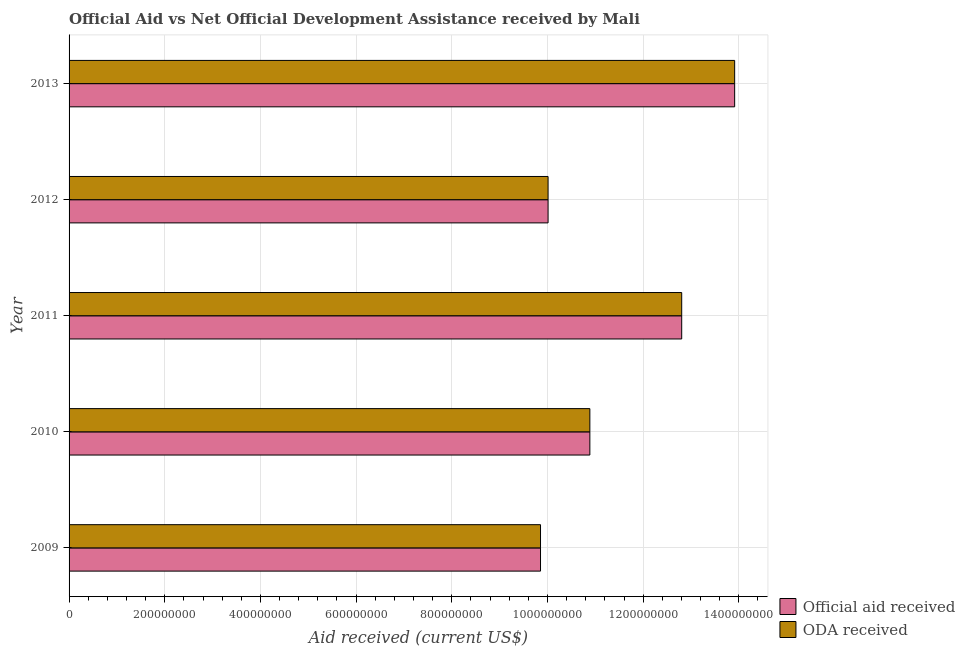Are the number of bars per tick equal to the number of legend labels?
Your answer should be compact. Yes. How many bars are there on the 1st tick from the top?
Provide a short and direct response. 2. In how many cases, is the number of bars for a given year not equal to the number of legend labels?
Offer a terse response. 0. What is the oda received in 2011?
Ensure brevity in your answer.  1.28e+09. Across all years, what is the maximum official aid received?
Provide a short and direct response. 1.39e+09. Across all years, what is the minimum oda received?
Provide a succinct answer. 9.85e+08. In which year was the oda received maximum?
Give a very brief answer. 2013. What is the total oda received in the graph?
Provide a short and direct response. 5.75e+09. What is the difference between the official aid received in 2011 and that in 2013?
Offer a terse response. -1.11e+08. What is the difference between the oda received in 2009 and the official aid received in 2013?
Provide a succinct answer. -4.06e+08. What is the average oda received per year?
Give a very brief answer. 1.15e+09. In the year 2009, what is the difference between the oda received and official aid received?
Keep it short and to the point. 0. In how many years, is the official aid received greater than 80000000 US$?
Give a very brief answer. 5. What is the ratio of the official aid received in 2009 to that in 2013?
Make the answer very short. 0.71. Is the oda received in 2010 less than that in 2013?
Give a very brief answer. Yes. What is the difference between the highest and the second highest oda received?
Provide a succinct answer. 1.11e+08. What is the difference between the highest and the lowest oda received?
Offer a terse response. 4.06e+08. In how many years, is the oda received greater than the average oda received taken over all years?
Give a very brief answer. 2. What does the 2nd bar from the top in 2009 represents?
Give a very brief answer. Official aid received. What does the 1st bar from the bottom in 2013 represents?
Your answer should be compact. Official aid received. What is the difference between two consecutive major ticks on the X-axis?
Provide a succinct answer. 2.00e+08. Where does the legend appear in the graph?
Offer a terse response. Bottom right. How many legend labels are there?
Ensure brevity in your answer.  2. What is the title of the graph?
Give a very brief answer. Official Aid vs Net Official Development Assistance received by Mali . Does "Depositors" appear as one of the legend labels in the graph?
Provide a succinct answer. No. What is the label or title of the X-axis?
Provide a succinct answer. Aid received (current US$). What is the label or title of the Y-axis?
Your response must be concise. Year. What is the Aid received (current US$) in Official aid received in 2009?
Make the answer very short. 9.85e+08. What is the Aid received (current US$) in ODA received in 2009?
Your answer should be compact. 9.85e+08. What is the Aid received (current US$) of Official aid received in 2010?
Offer a terse response. 1.09e+09. What is the Aid received (current US$) of ODA received in 2010?
Ensure brevity in your answer.  1.09e+09. What is the Aid received (current US$) of Official aid received in 2011?
Provide a short and direct response. 1.28e+09. What is the Aid received (current US$) in ODA received in 2011?
Your answer should be compact. 1.28e+09. What is the Aid received (current US$) of Official aid received in 2012?
Your answer should be compact. 1.00e+09. What is the Aid received (current US$) of ODA received in 2012?
Provide a short and direct response. 1.00e+09. What is the Aid received (current US$) of Official aid received in 2013?
Your answer should be compact. 1.39e+09. What is the Aid received (current US$) of ODA received in 2013?
Make the answer very short. 1.39e+09. Across all years, what is the maximum Aid received (current US$) in Official aid received?
Ensure brevity in your answer.  1.39e+09. Across all years, what is the maximum Aid received (current US$) in ODA received?
Your answer should be compact. 1.39e+09. Across all years, what is the minimum Aid received (current US$) in Official aid received?
Your answer should be very brief. 9.85e+08. Across all years, what is the minimum Aid received (current US$) in ODA received?
Give a very brief answer. 9.85e+08. What is the total Aid received (current US$) of Official aid received in the graph?
Offer a very short reply. 5.75e+09. What is the total Aid received (current US$) in ODA received in the graph?
Offer a very short reply. 5.75e+09. What is the difference between the Aid received (current US$) in Official aid received in 2009 and that in 2010?
Provide a succinct answer. -1.03e+08. What is the difference between the Aid received (current US$) in ODA received in 2009 and that in 2010?
Keep it short and to the point. -1.03e+08. What is the difference between the Aid received (current US$) of Official aid received in 2009 and that in 2011?
Offer a very short reply. -2.95e+08. What is the difference between the Aid received (current US$) of ODA received in 2009 and that in 2011?
Provide a short and direct response. -2.95e+08. What is the difference between the Aid received (current US$) in Official aid received in 2009 and that in 2012?
Your answer should be compact. -1.58e+07. What is the difference between the Aid received (current US$) in ODA received in 2009 and that in 2012?
Provide a short and direct response. -1.58e+07. What is the difference between the Aid received (current US$) of Official aid received in 2009 and that in 2013?
Offer a very short reply. -4.06e+08. What is the difference between the Aid received (current US$) in ODA received in 2009 and that in 2013?
Make the answer very short. -4.06e+08. What is the difference between the Aid received (current US$) in Official aid received in 2010 and that in 2011?
Your response must be concise. -1.92e+08. What is the difference between the Aid received (current US$) of ODA received in 2010 and that in 2011?
Your response must be concise. -1.92e+08. What is the difference between the Aid received (current US$) of Official aid received in 2010 and that in 2012?
Ensure brevity in your answer.  8.73e+07. What is the difference between the Aid received (current US$) of ODA received in 2010 and that in 2012?
Your answer should be very brief. 8.73e+07. What is the difference between the Aid received (current US$) of Official aid received in 2010 and that in 2013?
Your answer should be compact. -3.03e+08. What is the difference between the Aid received (current US$) of ODA received in 2010 and that in 2013?
Your answer should be very brief. -3.03e+08. What is the difference between the Aid received (current US$) in Official aid received in 2011 and that in 2012?
Offer a terse response. 2.79e+08. What is the difference between the Aid received (current US$) of ODA received in 2011 and that in 2012?
Give a very brief answer. 2.79e+08. What is the difference between the Aid received (current US$) in Official aid received in 2011 and that in 2013?
Offer a very short reply. -1.11e+08. What is the difference between the Aid received (current US$) of ODA received in 2011 and that in 2013?
Keep it short and to the point. -1.11e+08. What is the difference between the Aid received (current US$) of Official aid received in 2012 and that in 2013?
Your answer should be very brief. -3.90e+08. What is the difference between the Aid received (current US$) in ODA received in 2012 and that in 2013?
Offer a very short reply. -3.90e+08. What is the difference between the Aid received (current US$) in Official aid received in 2009 and the Aid received (current US$) in ODA received in 2010?
Keep it short and to the point. -1.03e+08. What is the difference between the Aid received (current US$) in Official aid received in 2009 and the Aid received (current US$) in ODA received in 2011?
Make the answer very short. -2.95e+08. What is the difference between the Aid received (current US$) in Official aid received in 2009 and the Aid received (current US$) in ODA received in 2012?
Your response must be concise. -1.58e+07. What is the difference between the Aid received (current US$) of Official aid received in 2009 and the Aid received (current US$) of ODA received in 2013?
Your answer should be compact. -4.06e+08. What is the difference between the Aid received (current US$) of Official aid received in 2010 and the Aid received (current US$) of ODA received in 2011?
Ensure brevity in your answer.  -1.92e+08. What is the difference between the Aid received (current US$) in Official aid received in 2010 and the Aid received (current US$) in ODA received in 2012?
Offer a very short reply. 8.73e+07. What is the difference between the Aid received (current US$) of Official aid received in 2010 and the Aid received (current US$) of ODA received in 2013?
Keep it short and to the point. -3.03e+08. What is the difference between the Aid received (current US$) in Official aid received in 2011 and the Aid received (current US$) in ODA received in 2012?
Give a very brief answer. 2.79e+08. What is the difference between the Aid received (current US$) in Official aid received in 2011 and the Aid received (current US$) in ODA received in 2013?
Provide a short and direct response. -1.11e+08. What is the difference between the Aid received (current US$) in Official aid received in 2012 and the Aid received (current US$) in ODA received in 2013?
Offer a very short reply. -3.90e+08. What is the average Aid received (current US$) of Official aid received per year?
Your answer should be compact. 1.15e+09. What is the average Aid received (current US$) of ODA received per year?
Provide a short and direct response. 1.15e+09. In the year 2009, what is the difference between the Aid received (current US$) in Official aid received and Aid received (current US$) in ODA received?
Make the answer very short. 0. In the year 2010, what is the difference between the Aid received (current US$) of Official aid received and Aid received (current US$) of ODA received?
Your answer should be very brief. 0. In the year 2011, what is the difference between the Aid received (current US$) in Official aid received and Aid received (current US$) in ODA received?
Your answer should be very brief. 0. In the year 2013, what is the difference between the Aid received (current US$) of Official aid received and Aid received (current US$) of ODA received?
Make the answer very short. 0. What is the ratio of the Aid received (current US$) of Official aid received in 2009 to that in 2010?
Provide a succinct answer. 0.91. What is the ratio of the Aid received (current US$) of ODA received in 2009 to that in 2010?
Your answer should be compact. 0.91. What is the ratio of the Aid received (current US$) in Official aid received in 2009 to that in 2011?
Make the answer very short. 0.77. What is the ratio of the Aid received (current US$) in ODA received in 2009 to that in 2011?
Keep it short and to the point. 0.77. What is the ratio of the Aid received (current US$) in Official aid received in 2009 to that in 2012?
Your answer should be very brief. 0.98. What is the ratio of the Aid received (current US$) of ODA received in 2009 to that in 2012?
Ensure brevity in your answer.  0.98. What is the ratio of the Aid received (current US$) in Official aid received in 2009 to that in 2013?
Make the answer very short. 0.71. What is the ratio of the Aid received (current US$) of ODA received in 2009 to that in 2013?
Give a very brief answer. 0.71. What is the ratio of the Aid received (current US$) of Official aid received in 2010 to that in 2011?
Offer a very short reply. 0.85. What is the ratio of the Aid received (current US$) of ODA received in 2010 to that in 2011?
Provide a short and direct response. 0.85. What is the ratio of the Aid received (current US$) of Official aid received in 2010 to that in 2012?
Make the answer very short. 1.09. What is the ratio of the Aid received (current US$) in ODA received in 2010 to that in 2012?
Make the answer very short. 1.09. What is the ratio of the Aid received (current US$) of Official aid received in 2010 to that in 2013?
Provide a short and direct response. 0.78. What is the ratio of the Aid received (current US$) in ODA received in 2010 to that in 2013?
Provide a short and direct response. 0.78. What is the ratio of the Aid received (current US$) of Official aid received in 2011 to that in 2012?
Give a very brief answer. 1.28. What is the ratio of the Aid received (current US$) of ODA received in 2011 to that in 2012?
Provide a short and direct response. 1.28. What is the ratio of the Aid received (current US$) of Official aid received in 2011 to that in 2013?
Your answer should be very brief. 0.92. What is the ratio of the Aid received (current US$) in ODA received in 2011 to that in 2013?
Your response must be concise. 0.92. What is the ratio of the Aid received (current US$) in Official aid received in 2012 to that in 2013?
Your response must be concise. 0.72. What is the ratio of the Aid received (current US$) in ODA received in 2012 to that in 2013?
Provide a succinct answer. 0.72. What is the difference between the highest and the second highest Aid received (current US$) in Official aid received?
Give a very brief answer. 1.11e+08. What is the difference between the highest and the second highest Aid received (current US$) of ODA received?
Offer a very short reply. 1.11e+08. What is the difference between the highest and the lowest Aid received (current US$) in Official aid received?
Provide a succinct answer. 4.06e+08. What is the difference between the highest and the lowest Aid received (current US$) in ODA received?
Offer a terse response. 4.06e+08. 